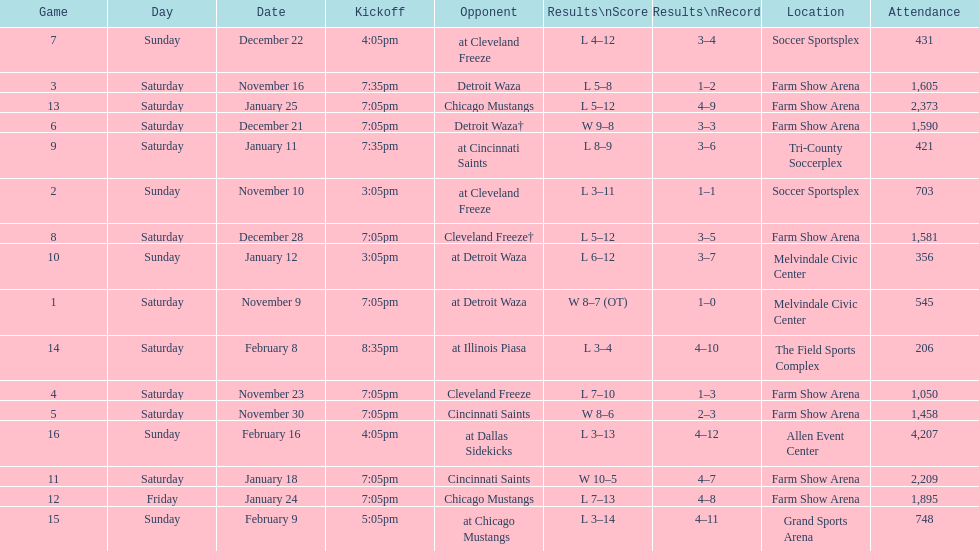What is the date of the game after december 22? December 28. 